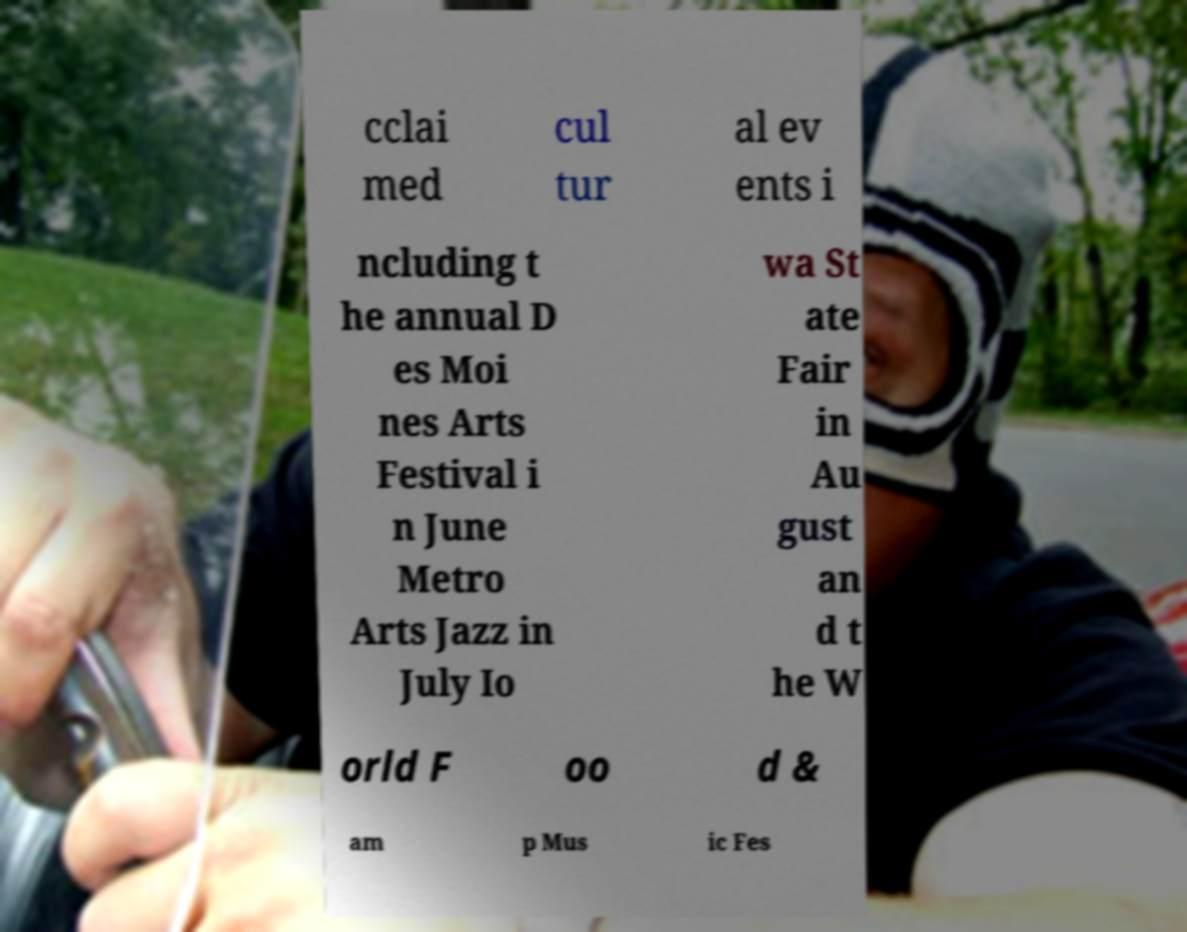Please read and relay the text visible in this image. What does it say? cclai med cul tur al ev ents i ncluding t he annual D es Moi nes Arts Festival i n June Metro Arts Jazz in July Io wa St ate Fair in Au gust an d t he W orld F oo d & am p Mus ic Fes 